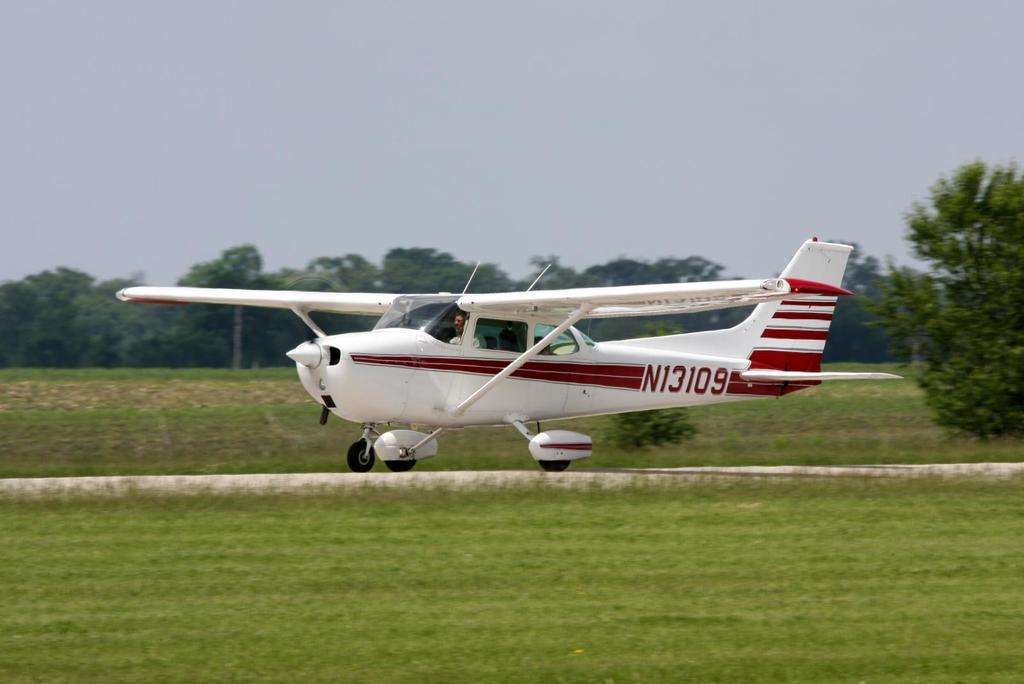What is the main subject of the image? The main subject of the image is an airplane on the ground. What type of terrain is visible in the image? There is grass visible in the image. What other natural elements can be seen in the image? There are trees in the image. What is visible in the background of the image? The sky is visible in the background of the image. What type of trade is being conducted between the airplane and the trees in the image? There is no trade being conducted between the airplane and the trees in the image, as they are not engaging in any activity together. 